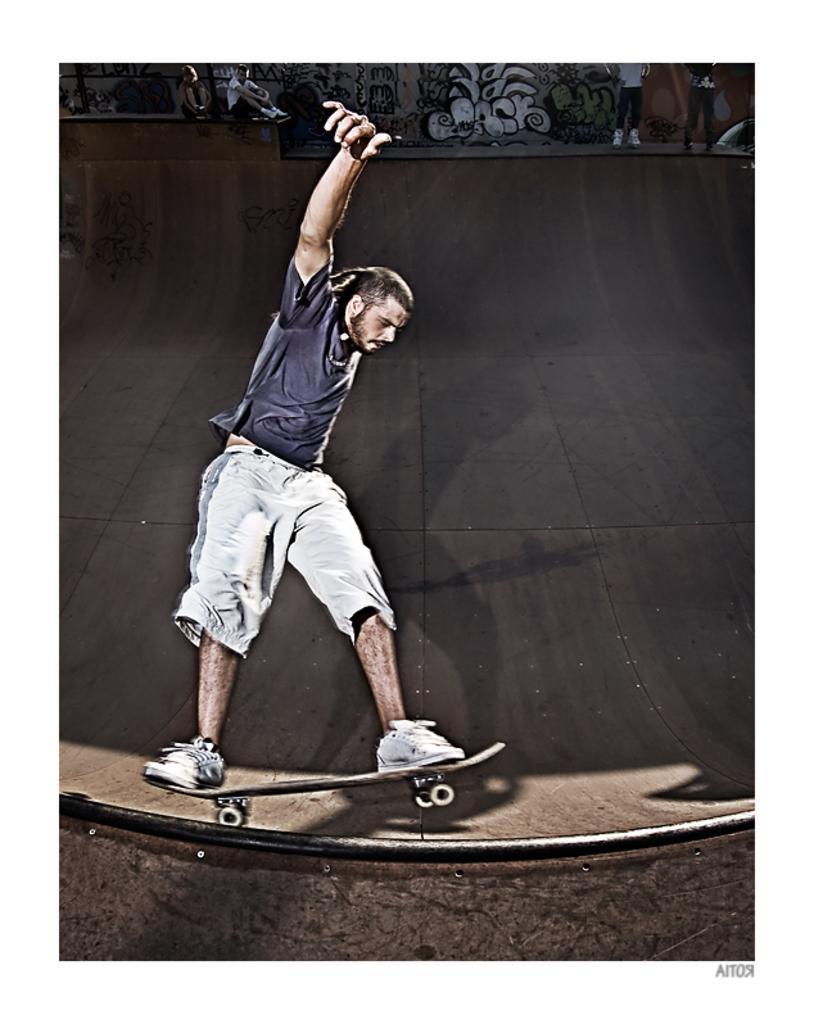Describe this image in one or two sentences. In this picture we can see a man standing on a skateboard and skating on a slide and in the background we can see some people. 